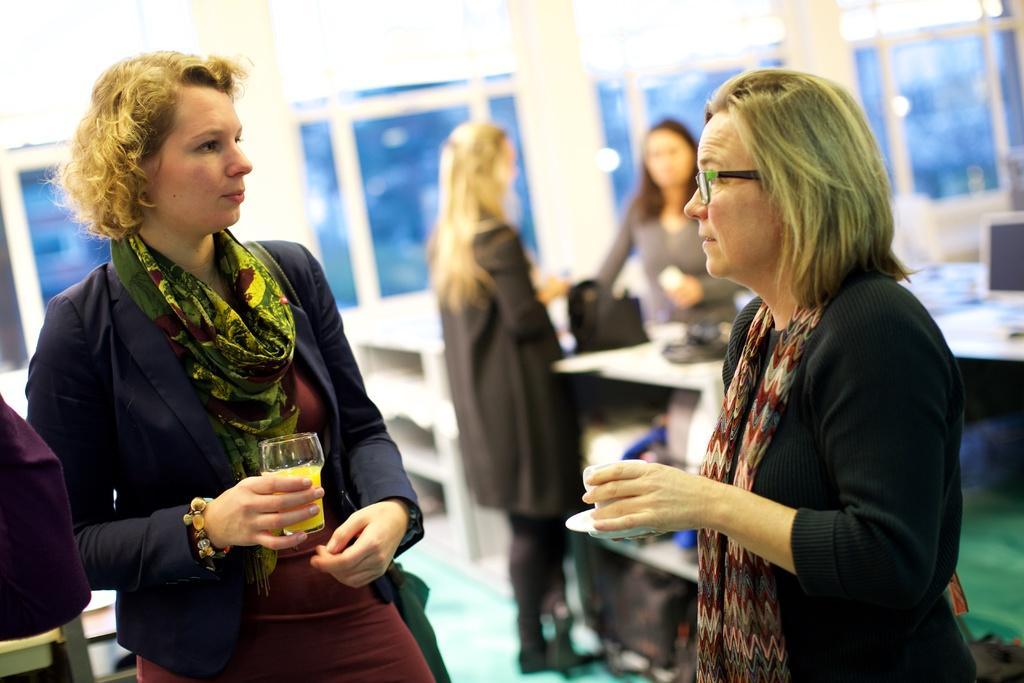In one or two sentences, can you explain what this image depicts? In this picture I can see two persons standing, a person holding a glass, another person holding a cup with a saucer, there are another two persons standing, those are looking like tables and there are some other objects. 